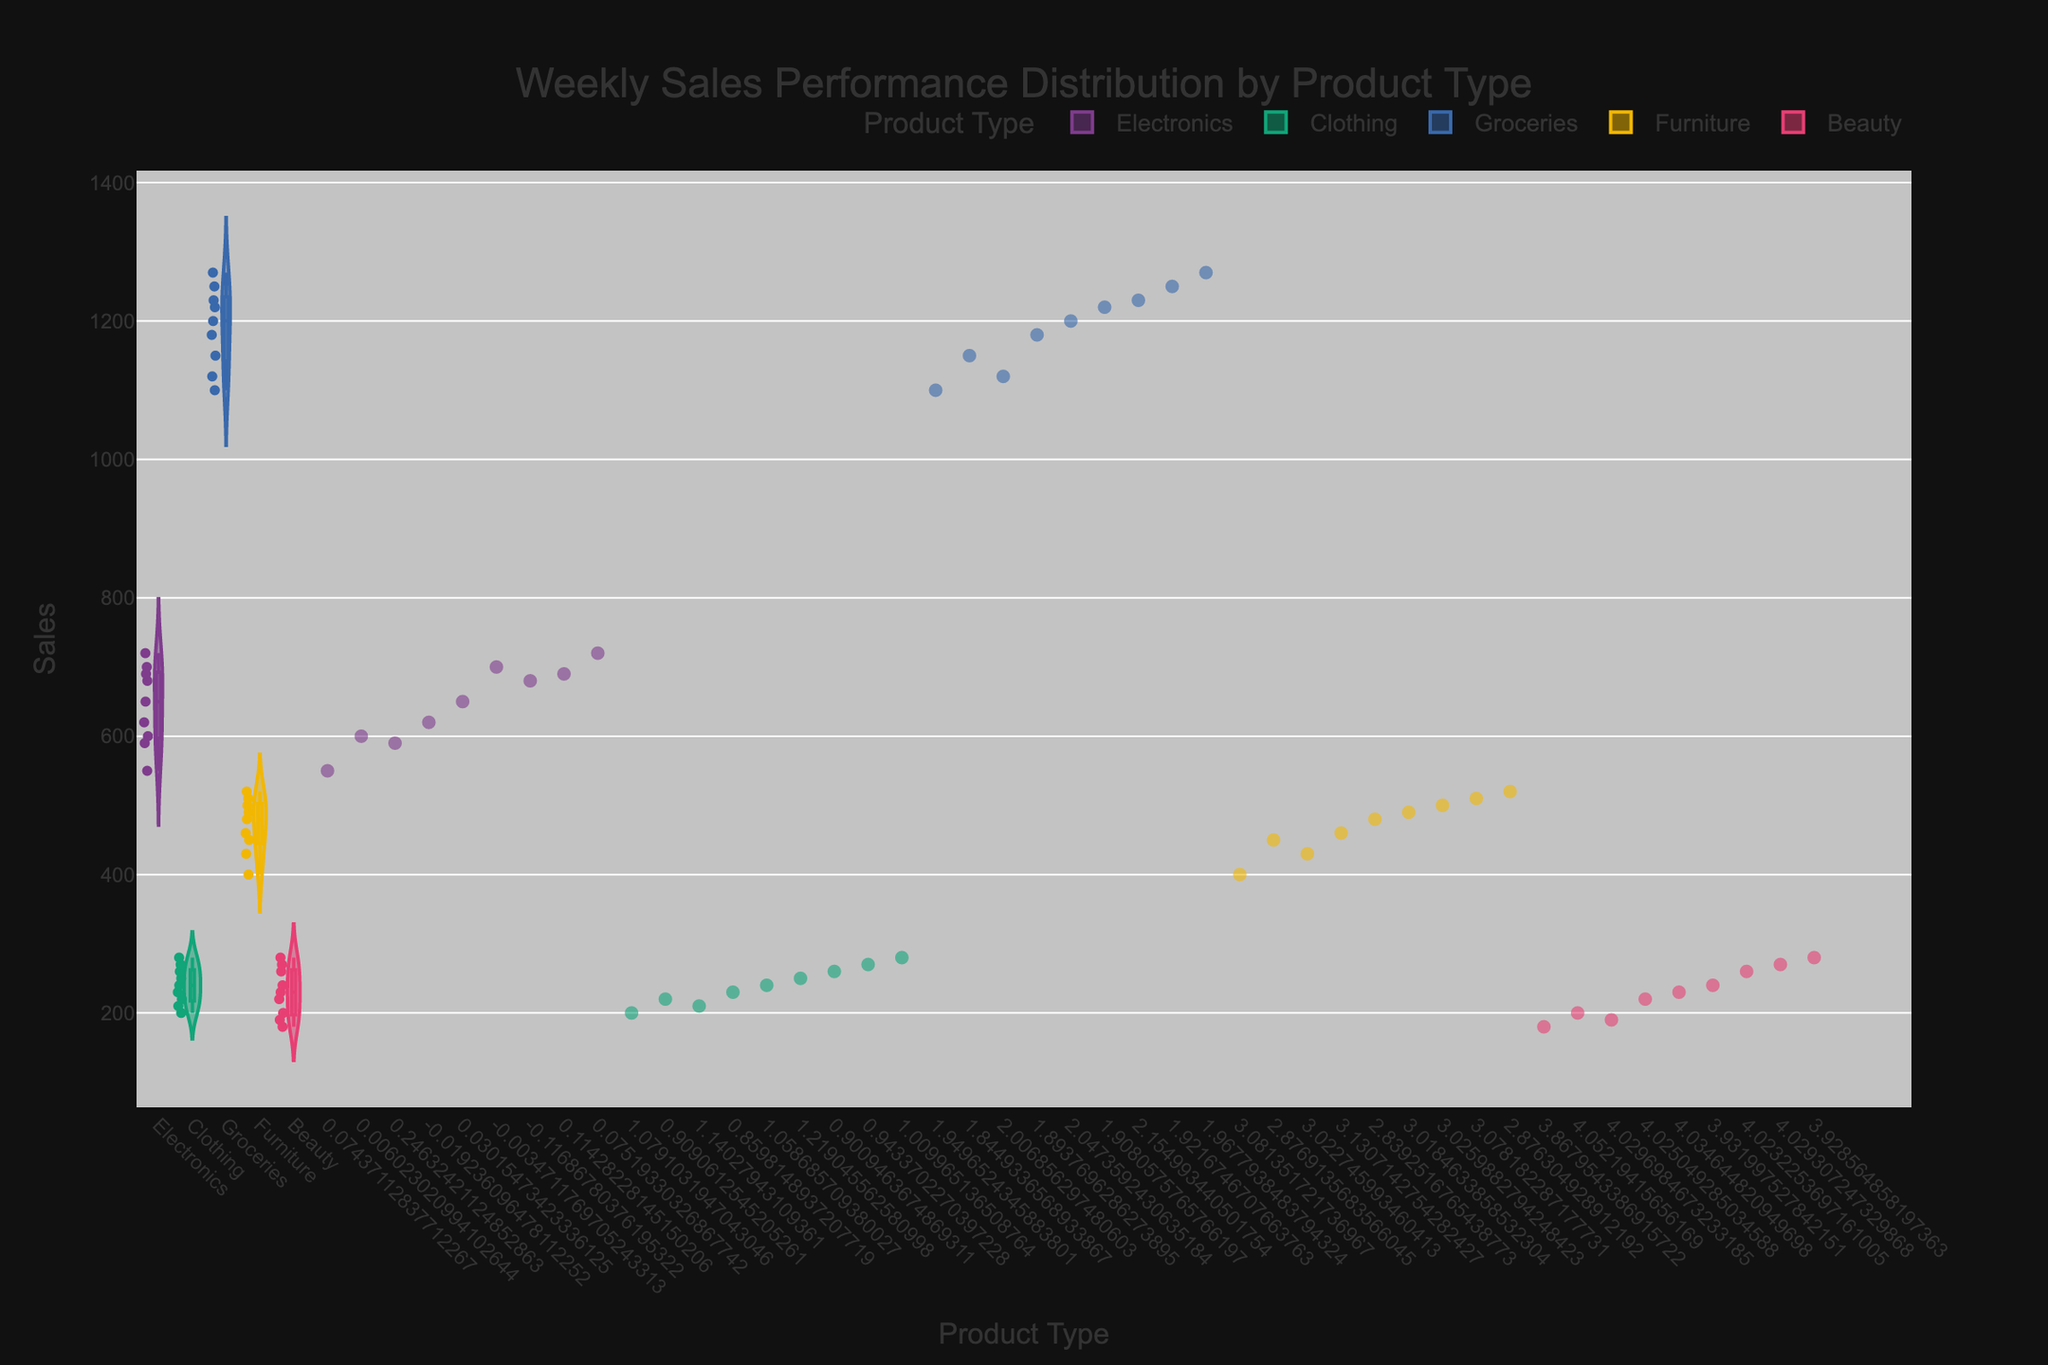What is the title of the figure? The title is prominently displayed at the top of the figure. It reads "Weekly Sales Performance Distribution by Product Type".
Answer: Weekly Sales Performance Distribution by Product Type What are the axes labels? The x-axis is labeled "Product Type" and the y-axis is labeled "Sales". The labels are directly below and next to the respective axes.
Answer: Product Type, Sales Which product type shows the widest distribution of sales? By looking at the width of each violin plot, Groceries show the widest spread in sales values, indicating a wide range of sales performances within this category.
Answer: Groceries What is the median sales value for Electronics? In the figure, the median value for each category can be seen inside the boxplot within each violin plot. The median sales value for Electronics is marked by the black horizontal line inside the box.
Answer: Approximately 650 Which product type has the highest average sales value? By comparing the central tendency of each violin plot, Groceries have the highest average sales value, as indicated by the higher position of the bulk of the distribution.
Answer: Groceries How do sales performance distributions for Clothing and Beauty compare? Comparing the shapes and medians of the distributions, both Clothing and Beauty have narrow distributions with lower sales values compared to other categories but Clothing's distribution is slightly wider.
Answer: Clothing has a slightly wider distribution than Beauty What can you infer about the outliers in Electronics sales? The outer markers in the Electronics violin plot show a few outliers, with sales figures significantly higher than the rest of the data points. These individual points are more isolated from the bulk of the distribution.
Answer: There are some higher outliers in Electronics sales How do the distribution spreads for Furniture compare to Clothing? The Furniture category shows a slightly wider spread in sales values than Clothing, suggesting that there is more variation in weekly sales performance in Furniture than in Clothing.
Answer: Furniture has a wider spread Which product category shows the least variation in sales? By examining the width of the violin plots, Beauty shows the least variation in sales values, indicating more consistent weekly sales.
Answer: Beauty 